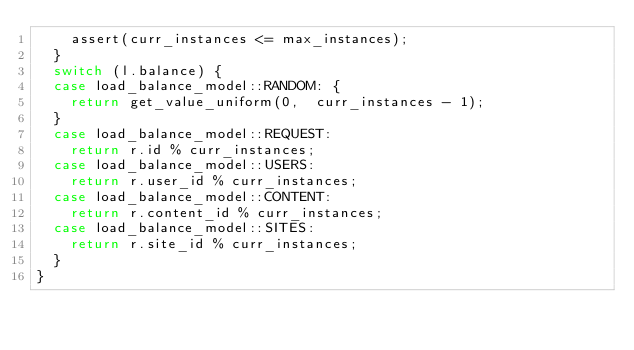Convert code to text. <code><loc_0><loc_0><loc_500><loc_500><_C++_>    assert(curr_instances <= max_instances);
  }
  switch (l.balance) {
  case load_balance_model::RANDOM: {
    return get_value_uniform(0,  curr_instances - 1);
  }
  case load_balance_model::REQUEST:
    return r.id % curr_instances;
  case load_balance_model::USERS:
    return r.user_id % curr_instances;
  case load_balance_model::CONTENT:
    return r.content_id % curr_instances;
  case load_balance_model::SITES:
    return r.site_id % curr_instances;
  }
}
</code> 